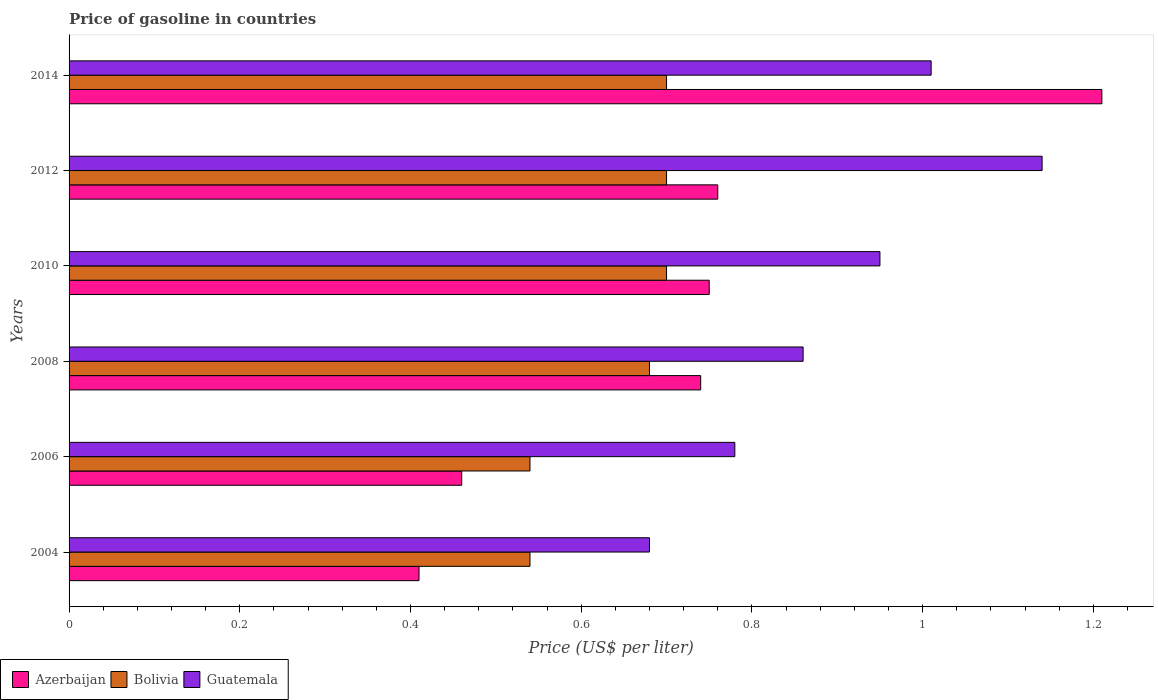How many different coloured bars are there?
Offer a terse response. 3. Are the number of bars per tick equal to the number of legend labels?
Ensure brevity in your answer.  Yes. Are the number of bars on each tick of the Y-axis equal?
Make the answer very short. Yes. What is the price of gasoline in Azerbaijan in 2006?
Your response must be concise. 0.46. Across all years, what is the maximum price of gasoline in Guatemala?
Provide a short and direct response. 1.14. Across all years, what is the minimum price of gasoline in Bolivia?
Provide a succinct answer. 0.54. In which year was the price of gasoline in Guatemala maximum?
Provide a short and direct response. 2012. In which year was the price of gasoline in Bolivia minimum?
Offer a very short reply. 2004. What is the total price of gasoline in Azerbaijan in the graph?
Your response must be concise. 4.33. What is the difference between the price of gasoline in Bolivia in 2008 and that in 2012?
Your response must be concise. -0.02. What is the difference between the price of gasoline in Azerbaijan in 2014 and the price of gasoline in Guatemala in 2012?
Your answer should be very brief. 0.07. What is the average price of gasoline in Azerbaijan per year?
Provide a short and direct response. 0.72. In the year 2012, what is the difference between the price of gasoline in Bolivia and price of gasoline in Guatemala?
Keep it short and to the point. -0.44. What is the ratio of the price of gasoline in Azerbaijan in 2006 to that in 2010?
Your answer should be compact. 0.61. Is the price of gasoline in Azerbaijan in 2004 less than that in 2012?
Your response must be concise. Yes. Is the difference between the price of gasoline in Bolivia in 2006 and 2014 greater than the difference between the price of gasoline in Guatemala in 2006 and 2014?
Offer a terse response. Yes. What is the difference between the highest and the second highest price of gasoline in Guatemala?
Your response must be concise. 0.13. In how many years, is the price of gasoline in Azerbaijan greater than the average price of gasoline in Azerbaijan taken over all years?
Make the answer very short. 4. Is the sum of the price of gasoline in Guatemala in 2006 and 2008 greater than the maximum price of gasoline in Bolivia across all years?
Make the answer very short. Yes. What does the 1st bar from the top in 2014 represents?
Your answer should be very brief. Guatemala. What does the 1st bar from the bottom in 2006 represents?
Provide a succinct answer. Azerbaijan. Is it the case that in every year, the sum of the price of gasoline in Guatemala and price of gasoline in Azerbaijan is greater than the price of gasoline in Bolivia?
Offer a terse response. Yes. Are the values on the major ticks of X-axis written in scientific E-notation?
Keep it short and to the point. No. Does the graph contain any zero values?
Offer a terse response. No. How are the legend labels stacked?
Your answer should be compact. Horizontal. What is the title of the graph?
Your answer should be compact. Price of gasoline in countries. What is the label or title of the X-axis?
Give a very brief answer. Price (US$ per liter). What is the label or title of the Y-axis?
Your answer should be compact. Years. What is the Price (US$ per liter) of Azerbaijan in 2004?
Your answer should be compact. 0.41. What is the Price (US$ per liter) of Bolivia in 2004?
Provide a succinct answer. 0.54. What is the Price (US$ per liter) in Guatemala in 2004?
Offer a very short reply. 0.68. What is the Price (US$ per liter) in Azerbaijan in 2006?
Offer a very short reply. 0.46. What is the Price (US$ per liter) of Bolivia in 2006?
Offer a very short reply. 0.54. What is the Price (US$ per liter) of Guatemala in 2006?
Provide a short and direct response. 0.78. What is the Price (US$ per liter) in Azerbaijan in 2008?
Your answer should be compact. 0.74. What is the Price (US$ per liter) of Bolivia in 2008?
Offer a very short reply. 0.68. What is the Price (US$ per liter) of Guatemala in 2008?
Your answer should be compact. 0.86. What is the Price (US$ per liter) of Azerbaijan in 2010?
Offer a terse response. 0.75. What is the Price (US$ per liter) in Bolivia in 2010?
Give a very brief answer. 0.7. What is the Price (US$ per liter) in Guatemala in 2010?
Make the answer very short. 0.95. What is the Price (US$ per liter) in Azerbaijan in 2012?
Your response must be concise. 0.76. What is the Price (US$ per liter) of Guatemala in 2012?
Your answer should be compact. 1.14. What is the Price (US$ per liter) of Azerbaijan in 2014?
Your response must be concise. 1.21. What is the Price (US$ per liter) of Bolivia in 2014?
Make the answer very short. 0.7. What is the Price (US$ per liter) in Guatemala in 2014?
Provide a succinct answer. 1.01. Across all years, what is the maximum Price (US$ per liter) in Azerbaijan?
Your answer should be compact. 1.21. Across all years, what is the maximum Price (US$ per liter) of Bolivia?
Provide a short and direct response. 0.7. Across all years, what is the maximum Price (US$ per liter) in Guatemala?
Your response must be concise. 1.14. Across all years, what is the minimum Price (US$ per liter) of Azerbaijan?
Provide a short and direct response. 0.41. Across all years, what is the minimum Price (US$ per liter) in Bolivia?
Your response must be concise. 0.54. Across all years, what is the minimum Price (US$ per liter) of Guatemala?
Offer a terse response. 0.68. What is the total Price (US$ per liter) in Azerbaijan in the graph?
Offer a terse response. 4.33. What is the total Price (US$ per liter) of Bolivia in the graph?
Make the answer very short. 3.86. What is the total Price (US$ per liter) of Guatemala in the graph?
Ensure brevity in your answer.  5.42. What is the difference between the Price (US$ per liter) of Bolivia in 2004 and that in 2006?
Your response must be concise. 0. What is the difference between the Price (US$ per liter) of Azerbaijan in 2004 and that in 2008?
Offer a very short reply. -0.33. What is the difference between the Price (US$ per liter) of Bolivia in 2004 and that in 2008?
Give a very brief answer. -0.14. What is the difference between the Price (US$ per liter) in Guatemala in 2004 and that in 2008?
Your answer should be compact. -0.18. What is the difference between the Price (US$ per liter) of Azerbaijan in 2004 and that in 2010?
Your response must be concise. -0.34. What is the difference between the Price (US$ per liter) in Bolivia in 2004 and that in 2010?
Ensure brevity in your answer.  -0.16. What is the difference between the Price (US$ per liter) of Guatemala in 2004 and that in 2010?
Give a very brief answer. -0.27. What is the difference between the Price (US$ per liter) in Azerbaijan in 2004 and that in 2012?
Offer a terse response. -0.35. What is the difference between the Price (US$ per liter) in Bolivia in 2004 and that in 2012?
Your answer should be very brief. -0.16. What is the difference between the Price (US$ per liter) of Guatemala in 2004 and that in 2012?
Offer a terse response. -0.46. What is the difference between the Price (US$ per liter) of Azerbaijan in 2004 and that in 2014?
Provide a short and direct response. -0.8. What is the difference between the Price (US$ per liter) of Bolivia in 2004 and that in 2014?
Ensure brevity in your answer.  -0.16. What is the difference between the Price (US$ per liter) of Guatemala in 2004 and that in 2014?
Provide a succinct answer. -0.33. What is the difference between the Price (US$ per liter) of Azerbaijan in 2006 and that in 2008?
Your response must be concise. -0.28. What is the difference between the Price (US$ per liter) in Bolivia in 2006 and that in 2008?
Provide a short and direct response. -0.14. What is the difference between the Price (US$ per liter) of Guatemala in 2006 and that in 2008?
Make the answer very short. -0.08. What is the difference between the Price (US$ per liter) of Azerbaijan in 2006 and that in 2010?
Provide a succinct answer. -0.29. What is the difference between the Price (US$ per liter) of Bolivia in 2006 and that in 2010?
Your response must be concise. -0.16. What is the difference between the Price (US$ per liter) of Guatemala in 2006 and that in 2010?
Provide a succinct answer. -0.17. What is the difference between the Price (US$ per liter) in Azerbaijan in 2006 and that in 2012?
Keep it short and to the point. -0.3. What is the difference between the Price (US$ per liter) of Bolivia in 2006 and that in 2012?
Your answer should be very brief. -0.16. What is the difference between the Price (US$ per liter) in Guatemala in 2006 and that in 2012?
Your answer should be very brief. -0.36. What is the difference between the Price (US$ per liter) in Azerbaijan in 2006 and that in 2014?
Your answer should be very brief. -0.75. What is the difference between the Price (US$ per liter) in Bolivia in 2006 and that in 2014?
Ensure brevity in your answer.  -0.16. What is the difference between the Price (US$ per liter) of Guatemala in 2006 and that in 2014?
Ensure brevity in your answer.  -0.23. What is the difference between the Price (US$ per liter) of Azerbaijan in 2008 and that in 2010?
Offer a terse response. -0.01. What is the difference between the Price (US$ per liter) in Bolivia in 2008 and that in 2010?
Your response must be concise. -0.02. What is the difference between the Price (US$ per liter) of Guatemala in 2008 and that in 2010?
Offer a very short reply. -0.09. What is the difference between the Price (US$ per liter) in Azerbaijan in 2008 and that in 2012?
Offer a terse response. -0.02. What is the difference between the Price (US$ per liter) of Bolivia in 2008 and that in 2012?
Provide a succinct answer. -0.02. What is the difference between the Price (US$ per liter) of Guatemala in 2008 and that in 2012?
Keep it short and to the point. -0.28. What is the difference between the Price (US$ per liter) in Azerbaijan in 2008 and that in 2014?
Provide a short and direct response. -0.47. What is the difference between the Price (US$ per liter) in Bolivia in 2008 and that in 2014?
Your answer should be compact. -0.02. What is the difference between the Price (US$ per liter) of Guatemala in 2008 and that in 2014?
Your answer should be very brief. -0.15. What is the difference between the Price (US$ per liter) of Azerbaijan in 2010 and that in 2012?
Your response must be concise. -0.01. What is the difference between the Price (US$ per liter) in Guatemala in 2010 and that in 2012?
Offer a very short reply. -0.19. What is the difference between the Price (US$ per liter) of Azerbaijan in 2010 and that in 2014?
Offer a terse response. -0.46. What is the difference between the Price (US$ per liter) of Guatemala in 2010 and that in 2014?
Your answer should be compact. -0.06. What is the difference between the Price (US$ per liter) in Azerbaijan in 2012 and that in 2014?
Offer a terse response. -0.45. What is the difference between the Price (US$ per liter) of Guatemala in 2012 and that in 2014?
Give a very brief answer. 0.13. What is the difference between the Price (US$ per liter) of Azerbaijan in 2004 and the Price (US$ per liter) of Bolivia in 2006?
Your answer should be very brief. -0.13. What is the difference between the Price (US$ per liter) of Azerbaijan in 2004 and the Price (US$ per liter) of Guatemala in 2006?
Your answer should be compact. -0.37. What is the difference between the Price (US$ per liter) in Bolivia in 2004 and the Price (US$ per liter) in Guatemala in 2006?
Your answer should be very brief. -0.24. What is the difference between the Price (US$ per liter) of Azerbaijan in 2004 and the Price (US$ per liter) of Bolivia in 2008?
Your answer should be very brief. -0.27. What is the difference between the Price (US$ per liter) in Azerbaijan in 2004 and the Price (US$ per liter) in Guatemala in 2008?
Your answer should be very brief. -0.45. What is the difference between the Price (US$ per liter) of Bolivia in 2004 and the Price (US$ per liter) of Guatemala in 2008?
Provide a succinct answer. -0.32. What is the difference between the Price (US$ per liter) in Azerbaijan in 2004 and the Price (US$ per liter) in Bolivia in 2010?
Offer a very short reply. -0.29. What is the difference between the Price (US$ per liter) in Azerbaijan in 2004 and the Price (US$ per liter) in Guatemala in 2010?
Your answer should be compact. -0.54. What is the difference between the Price (US$ per liter) in Bolivia in 2004 and the Price (US$ per liter) in Guatemala in 2010?
Your response must be concise. -0.41. What is the difference between the Price (US$ per liter) of Azerbaijan in 2004 and the Price (US$ per liter) of Bolivia in 2012?
Your answer should be very brief. -0.29. What is the difference between the Price (US$ per liter) in Azerbaijan in 2004 and the Price (US$ per liter) in Guatemala in 2012?
Provide a succinct answer. -0.73. What is the difference between the Price (US$ per liter) of Bolivia in 2004 and the Price (US$ per liter) of Guatemala in 2012?
Provide a succinct answer. -0.6. What is the difference between the Price (US$ per liter) in Azerbaijan in 2004 and the Price (US$ per liter) in Bolivia in 2014?
Offer a very short reply. -0.29. What is the difference between the Price (US$ per liter) in Bolivia in 2004 and the Price (US$ per liter) in Guatemala in 2014?
Keep it short and to the point. -0.47. What is the difference between the Price (US$ per liter) of Azerbaijan in 2006 and the Price (US$ per liter) of Bolivia in 2008?
Your answer should be compact. -0.22. What is the difference between the Price (US$ per liter) in Bolivia in 2006 and the Price (US$ per liter) in Guatemala in 2008?
Your answer should be very brief. -0.32. What is the difference between the Price (US$ per liter) in Azerbaijan in 2006 and the Price (US$ per liter) in Bolivia in 2010?
Provide a succinct answer. -0.24. What is the difference between the Price (US$ per liter) of Azerbaijan in 2006 and the Price (US$ per liter) of Guatemala in 2010?
Your answer should be compact. -0.49. What is the difference between the Price (US$ per liter) of Bolivia in 2006 and the Price (US$ per liter) of Guatemala in 2010?
Provide a succinct answer. -0.41. What is the difference between the Price (US$ per liter) in Azerbaijan in 2006 and the Price (US$ per liter) in Bolivia in 2012?
Offer a very short reply. -0.24. What is the difference between the Price (US$ per liter) in Azerbaijan in 2006 and the Price (US$ per liter) in Guatemala in 2012?
Make the answer very short. -0.68. What is the difference between the Price (US$ per liter) of Bolivia in 2006 and the Price (US$ per liter) of Guatemala in 2012?
Offer a terse response. -0.6. What is the difference between the Price (US$ per liter) of Azerbaijan in 2006 and the Price (US$ per liter) of Bolivia in 2014?
Provide a succinct answer. -0.24. What is the difference between the Price (US$ per liter) in Azerbaijan in 2006 and the Price (US$ per liter) in Guatemala in 2014?
Your answer should be very brief. -0.55. What is the difference between the Price (US$ per liter) in Bolivia in 2006 and the Price (US$ per liter) in Guatemala in 2014?
Your response must be concise. -0.47. What is the difference between the Price (US$ per liter) of Azerbaijan in 2008 and the Price (US$ per liter) of Bolivia in 2010?
Make the answer very short. 0.04. What is the difference between the Price (US$ per liter) of Azerbaijan in 2008 and the Price (US$ per liter) of Guatemala in 2010?
Make the answer very short. -0.21. What is the difference between the Price (US$ per liter) of Bolivia in 2008 and the Price (US$ per liter) of Guatemala in 2010?
Provide a short and direct response. -0.27. What is the difference between the Price (US$ per liter) of Azerbaijan in 2008 and the Price (US$ per liter) of Bolivia in 2012?
Offer a terse response. 0.04. What is the difference between the Price (US$ per liter) of Azerbaijan in 2008 and the Price (US$ per liter) of Guatemala in 2012?
Ensure brevity in your answer.  -0.4. What is the difference between the Price (US$ per liter) in Bolivia in 2008 and the Price (US$ per liter) in Guatemala in 2012?
Ensure brevity in your answer.  -0.46. What is the difference between the Price (US$ per liter) in Azerbaijan in 2008 and the Price (US$ per liter) in Guatemala in 2014?
Provide a short and direct response. -0.27. What is the difference between the Price (US$ per liter) of Bolivia in 2008 and the Price (US$ per liter) of Guatemala in 2014?
Your answer should be very brief. -0.33. What is the difference between the Price (US$ per liter) of Azerbaijan in 2010 and the Price (US$ per liter) of Bolivia in 2012?
Your answer should be compact. 0.05. What is the difference between the Price (US$ per liter) in Azerbaijan in 2010 and the Price (US$ per liter) in Guatemala in 2012?
Your answer should be compact. -0.39. What is the difference between the Price (US$ per liter) of Bolivia in 2010 and the Price (US$ per liter) of Guatemala in 2012?
Provide a succinct answer. -0.44. What is the difference between the Price (US$ per liter) of Azerbaijan in 2010 and the Price (US$ per liter) of Bolivia in 2014?
Give a very brief answer. 0.05. What is the difference between the Price (US$ per liter) in Azerbaijan in 2010 and the Price (US$ per liter) in Guatemala in 2014?
Provide a short and direct response. -0.26. What is the difference between the Price (US$ per liter) of Bolivia in 2010 and the Price (US$ per liter) of Guatemala in 2014?
Your answer should be compact. -0.31. What is the difference between the Price (US$ per liter) in Azerbaijan in 2012 and the Price (US$ per liter) in Guatemala in 2014?
Provide a short and direct response. -0.25. What is the difference between the Price (US$ per liter) of Bolivia in 2012 and the Price (US$ per liter) of Guatemala in 2014?
Make the answer very short. -0.31. What is the average Price (US$ per liter) in Azerbaijan per year?
Provide a succinct answer. 0.72. What is the average Price (US$ per liter) of Bolivia per year?
Give a very brief answer. 0.64. What is the average Price (US$ per liter) of Guatemala per year?
Provide a succinct answer. 0.9. In the year 2004, what is the difference between the Price (US$ per liter) in Azerbaijan and Price (US$ per liter) in Bolivia?
Make the answer very short. -0.13. In the year 2004, what is the difference between the Price (US$ per liter) in Azerbaijan and Price (US$ per liter) in Guatemala?
Your answer should be very brief. -0.27. In the year 2004, what is the difference between the Price (US$ per liter) of Bolivia and Price (US$ per liter) of Guatemala?
Keep it short and to the point. -0.14. In the year 2006, what is the difference between the Price (US$ per liter) in Azerbaijan and Price (US$ per liter) in Bolivia?
Your answer should be compact. -0.08. In the year 2006, what is the difference between the Price (US$ per liter) of Azerbaijan and Price (US$ per liter) of Guatemala?
Keep it short and to the point. -0.32. In the year 2006, what is the difference between the Price (US$ per liter) in Bolivia and Price (US$ per liter) in Guatemala?
Keep it short and to the point. -0.24. In the year 2008, what is the difference between the Price (US$ per liter) in Azerbaijan and Price (US$ per liter) in Guatemala?
Your answer should be compact. -0.12. In the year 2008, what is the difference between the Price (US$ per liter) in Bolivia and Price (US$ per liter) in Guatemala?
Your answer should be very brief. -0.18. In the year 2010, what is the difference between the Price (US$ per liter) of Azerbaijan and Price (US$ per liter) of Bolivia?
Offer a very short reply. 0.05. In the year 2012, what is the difference between the Price (US$ per liter) of Azerbaijan and Price (US$ per liter) of Bolivia?
Keep it short and to the point. 0.06. In the year 2012, what is the difference between the Price (US$ per liter) of Azerbaijan and Price (US$ per liter) of Guatemala?
Provide a succinct answer. -0.38. In the year 2012, what is the difference between the Price (US$ per liter) of Bolivia and Price (US$ per liter) of Guatemala?
Your response must be concise. -0.44. In the year 2014, what is the difference between the Price (US$ per liter) of Azerbaijan and Price (US$ per liter) of Bolivia?
Provide a short and direct response. 0.51. In the year 2014, what is the difference between the Price (US$ per liter) of Azerbaijan and Price (US$ per liter) of Guatemala?
Give a very brief answer. 0.2. In the year 2014, what is the difference between the Price (US$ per liter) of Bolivia and Price (US$ per liter) of Guatemala?
Your answer should be compact. -0.31. What is the ratio of the Price (US$ per liter) in Azerbaijan in 2004 to that in 2006?
Ensure brevity in your answer.  0.89. What is the ratio of the Price (US$ per liter) in Guatemala in 2004 to that in 2006?
Keep it short and to the point. 0.87. What is the ratio of the Price (US$ per liter) of Azerbaijan in 2004 to that in 2008?
Make the answer very short. 0.55. What is the ratio of the Price (US$ per liter) in Bolivia in 2004 to that in 2008?
Ensure brevity in your answer.  0.79. What is the ratio of the Price (US$ per liter) in Guatemala in 2004 to that in 2008?
Keep it short and to the point. 0.79. What is the ratio of the Price (US$ per liter) in Azerbaijan in 2004 to that in 2010?
Your answer should be very brief. 0.55. What is the ratio of the Price (US$ per liter) in Bolivia in 2004 to that in 2010?
Offer a very short reply. 0.77. What is the ratio of the Price (US$ per liter) of Guatemala in 2004 to that in 2010?
Ensure brevity in your answer.  0.72. What is the ratio of the Price (US$ per liter) in Azerbaijan in 2004 to that in 2012?
Give a very brief answer. 0.54. What is the ratio of the Price (US$ per liter) of Bolivia in 2004 to that in 2012?
Give a very brief answer. 0.77. What is the ratio of the Price (US$ per liter) of Guatemala in 2004 to that in 2012?
Ensure brevity in your answer.  0.6. What is the ratio of the Price (US$ per liter) in Azerbaijan in 2004 to that in 2014?
Give a very brief answer. 0.34. What is the ratio of the Price (US$ per liter) in Bolivia in 2004 to that in 2014?
Offer a very short reply. 0.77. What is the ratio of the Price (US$ per liter) in Guatemala in 2004 to that in 2014?
Your answer should be compact. 0.67. What is the ratio of the Price (US$ per liter) in Azerbaijan in 2006 to that in 2008?
Provide a short and direct response. 0.62. What is the ratio of the Price (US$ per liter) in Bolivia in 2006 to that in 2008?
Give a very brief answer. 0.79. What is the ratio of the Price (US$ per liter) of Guatemala in 2006 to that in 2008?
Keep it short and to the point. 0.91. What is the ratio of the Price (US$ per liter) of Azerbaijan in 2006 to that in 2010?
Give a very brief answer. 0.61. What is the ratio of the Price (US$ per liter) of Bolivia in 2006 to that in 2010?
Keep it short and to the point. 0.77. What is the ratio of the Price (US$ per liter) of Guatemala in 2006 to that in 2010?
Ensure brevity in your answer.  0.82. What is the ratio of the Price (US$ per liter) in Azerbaijan in 2006 to that in 2012?
Your answer should be compact. 0.61. What is the ratio of the Price (US$ per liter) in Bolivia in 2006 to that in 2012?
Your answer should be compact. 0.77. What is the ratio of the Price (US$ per liter) in Guatemala in 2006 to that in 2012?
Keep it short and to the point. 0.68. What is the ratio of the Price (US$ per liter) in Azerbaijan in 2006 to that in 2014?
Your answer should be very brief. 0.38. What is the ratio of the Price (US$ per liter) of Bolivia in 2006 to that in 2014?
Offer a very short reply. 0.77. What is the ratio of the Price (US$ per liter) of Guatemala in 2006 to that in 2014?
Keep it short and to the point. 0.77. What is the ratio of the Price (US$ per liter) of Azerbaijan in 2008 to that in 2010?
Your response must be concise. 0.99. What is the ratio of the Price (US$ per liter) in Bolivia in 2008 to that in 2010?
Provide a short and direct response. 0.97. What is the ratio of the Price (US$ per liter) in Guatemala in 2008 to that in 2010?
Ensure brevity in your answer.  0.91. What is the ratio of the Price (US$ per liter) in Azerbaijan in 2008 to that in 2012?
Offer a very short reply. 0.97. What is the ratio of the Price (US$ per liter) of Bolivia in 2008 to that in 2012?
Provide a succinct answer. 0.97. What is the ratio of the Price (US$ per liter) of Guatemala in 2008 to that in 2012?
Keep it short and to the point. 0.75. What is the ratio of the Price (US$ per liter) in Azerbaijan in 2008 to that in 2014?
Provide a short and direct response. 0.61. What is the ratio of the Price (US$ per liter) of Bolivia in 2008 to that in 2014?
Your answer should be compact. 0.97. What is the ratio of the Price (US$ per liter) in Guatemala in 2008 to that in 2014?
Make the answer very short. 0.85. What is the ratio of the Price (US$ per liter) in Azerbaijan in 2010 to that in 2012?
Provide a succinct answer. 0.99. What is the ratio of the Price (US$ per liter) in Bolivia in 2010 to that in 2012?
Your answer should be very brief. 1. What is the ratio of the Price (US$ per liter) of Azerbaijan in 2010 to that in 2014?
Provide a short and direct response. 0.62. What is the ratio of the Price (US$ per liter) in Guatemala in 2010 to that in 2014?
Provide a short and direct response. 0.94. What is the ratio of the Price (US$ per liter) of Azerbaijan in 2012 to that in 2014?
Provide a short and direct response. 0.63. What is the ratio of the Price (US$ per liter) in Guatemala in 2012 to that in 2014?
Make the answer very short. 1.13. What is the difference between the highest and the second highest Price (US$ per liter) in Azerbaijan?
Give a very brief answer. 0.45. What is the difference between the highest and the second highest Price (US$ per liter) of Guatemala?
Make the answer very short. 0.13. What is the difference between the highest and the lowest Price (US$ per liter) of Azerbaijan?
Make the answer very short. 0.8. What is the difference between the highest and the lowest Price (US$ per liter) of Bolivia?
Offer a terse response. 0.16. What is the difference between the highest and the lowest Price (US$ per liter) of Guatemala?
Your response must be concise. 0.46. 